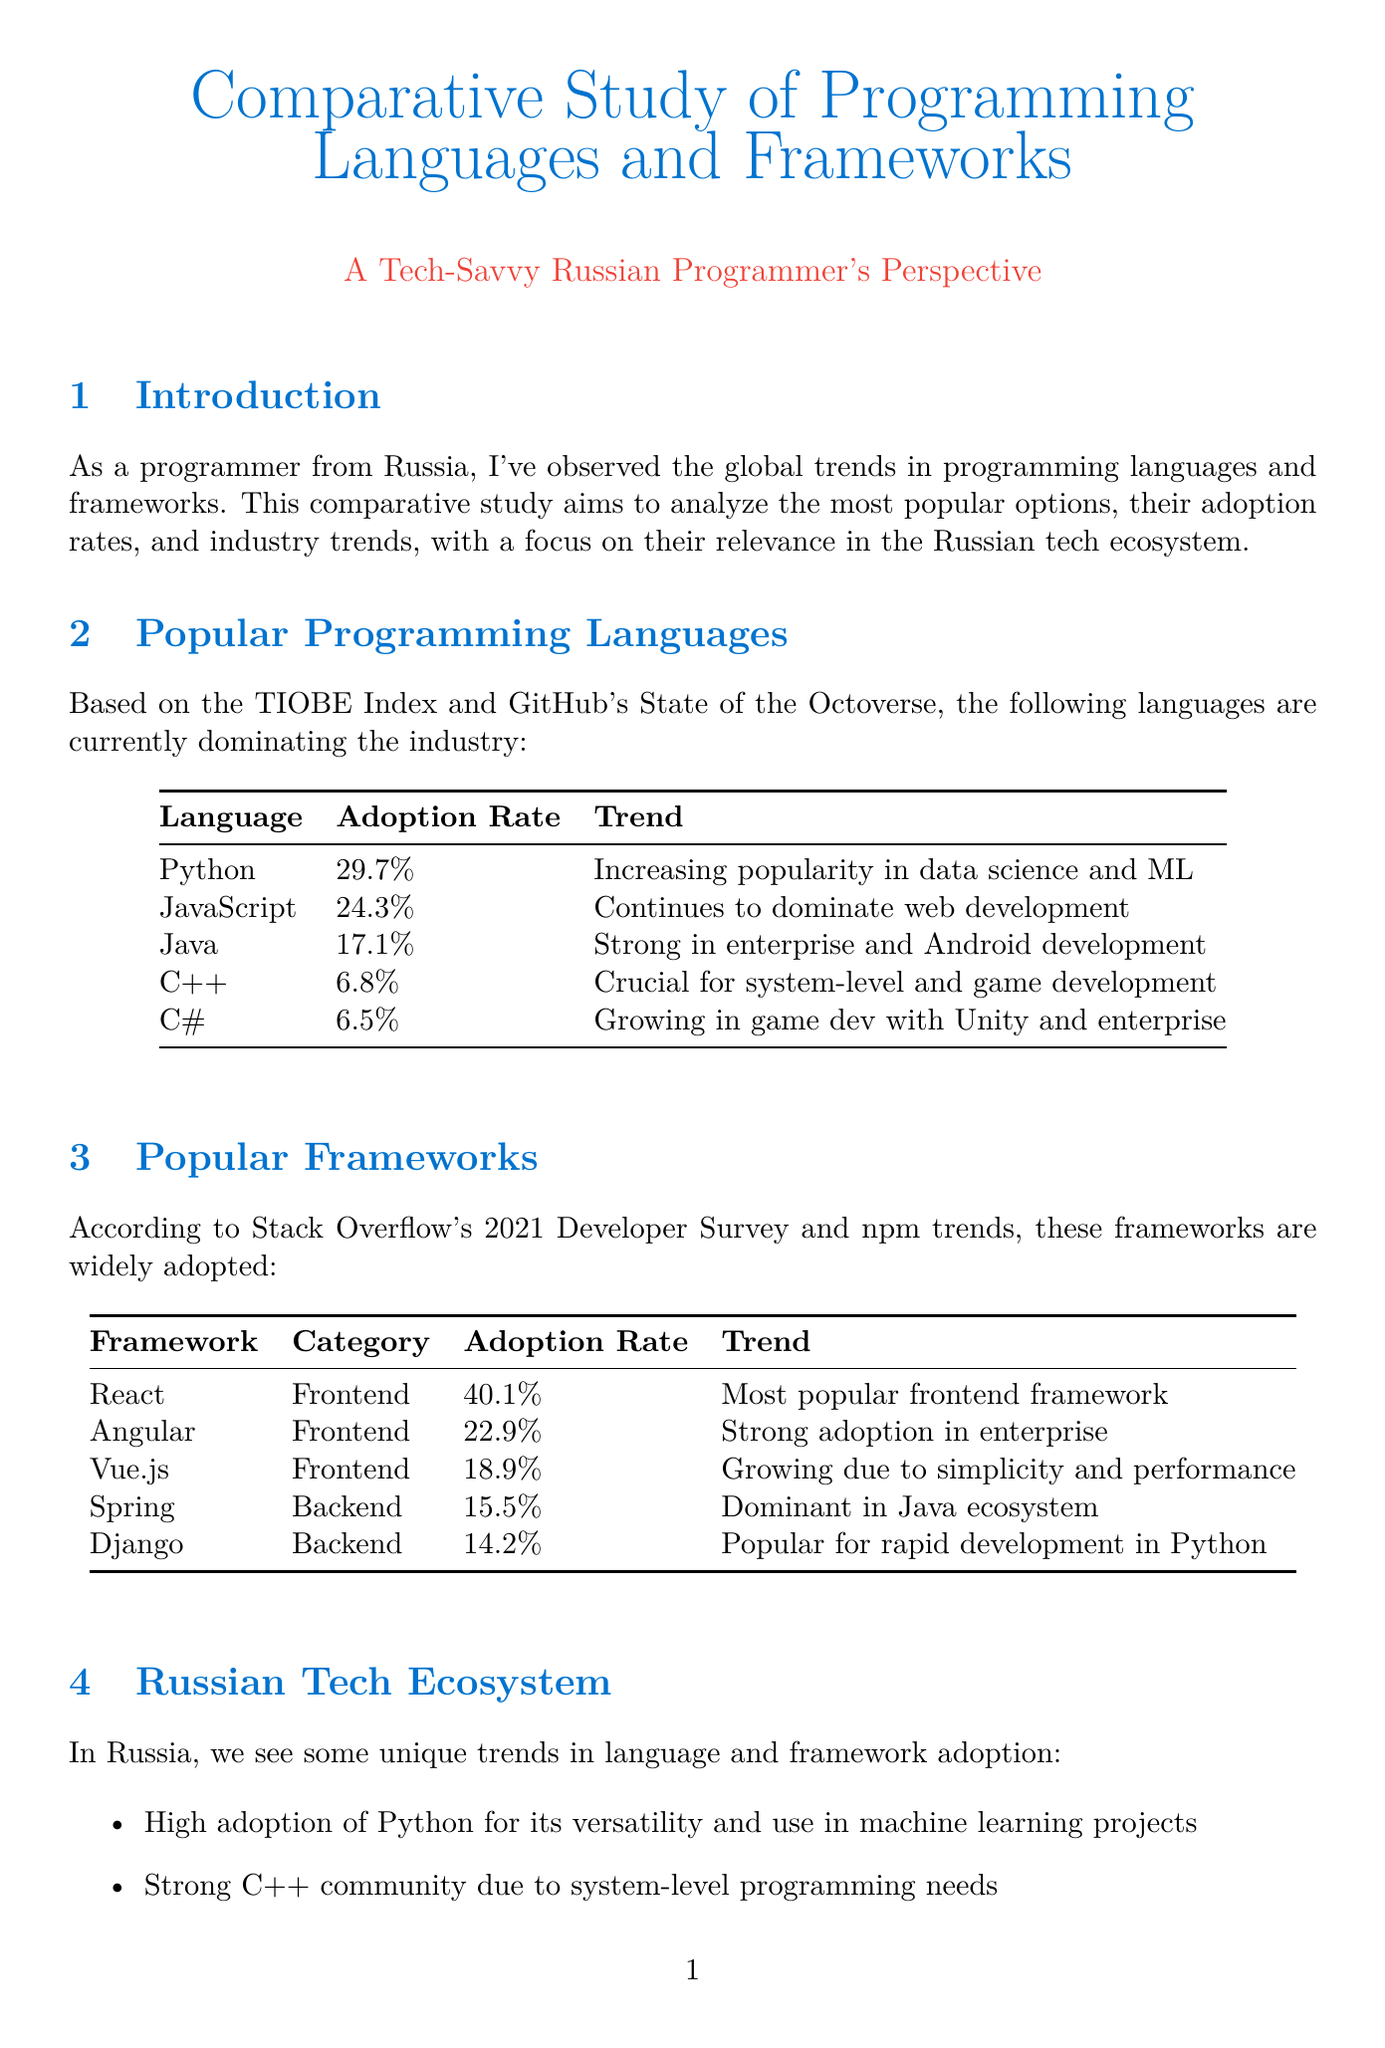What is the adoption rate of Python? Python's adoption rate is listed in the "Popular Programming Languages" section of the document, which states it is 29.7%.
Answer: 29.7% What framework has the highest adoption rate? The highest adoption rate is found in the "Popular Frameworks" section, where React is noted to have an adoption rate of 40.1%.
Answer: 40.1% Which language is noted for strong enterprise and Android development? The "Popular Programming Languages" section mentions Java as being strong in enterprise and Android development.
Answer: Java What trend is associated with JavaScript? The trend for JavaScript, highlighted in the "Popular Programming Languages" section, indicates it continues to dominate web development.
Answer: Continues to dominate web development How many unique trends in language and framework adoption are identified in the Russian tech ecosystem? The "Russian Tech Ecosystem" section lists five unique trends regarding language and framework adoption in Russia.
Answer: Five Which backend framework is popular for rapid development in Python? The "Popular Frameworks" section states that Django is popular for rapid development in the Python ecosystem.
Answer: Django What is a key trend shaping the programming landscape? The "Industry Trends" section lists several trends; one example is the rise of low-code and no-code platforms.
Answer: Rise of low-code and no-code platforms What is the primary data source mentioned for programming language trends? The "Data Sources" section lists TIOBE Index as a primary source of information related to programming languages.
Answer: TIOBE Index 